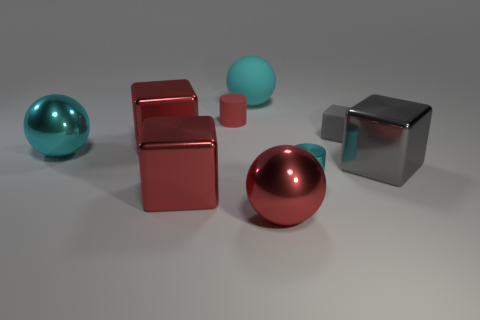What number of other things are made of the same material as the big gray object?
Your answer should be compact. 5. What size is the red rubber object?
Keep it short and to the point. Small. What number of other things are there of the same color as the small rubber cylinder?
Give a very brief answer. 3. What is the color of the shiny thing that is on the left side of the tiny cyan metal object and on the right side of the small rubber cylinder?
Make the answer very short. Red. How many blue rubber blocks are there?
Offer a terse response. 0. Does the large gray cube have the same material as the tiny red thing?
Offer a terse response. No. There is a gray thing that is behind the cyan object left of the red block behind the gray metallic object; what is its shape?
Offer a very short reply. Cube. Do the large red thing on the right side of the cyan rubber thing and the big block in front of the small cyan thing have the same material?
Provide a succinct answer. Yes. What material is the tiny cyan cylinder?
Offer a terse response. Metal. How many small cyan shiny things are the same shape as the red matte thing?
Provide a short and direct response. 1. 